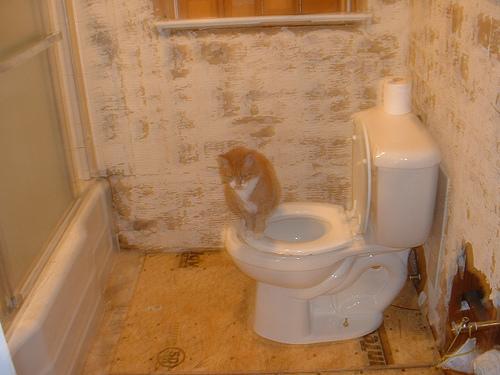Is the cat in the toilet?
Short answer required. No. What is sitting on the toilet tank?
Concise answer only. Cat. Is there a toilet paper holder?
Quick response, please. No. Where is the cat?
Concise answer only. On toilet. 